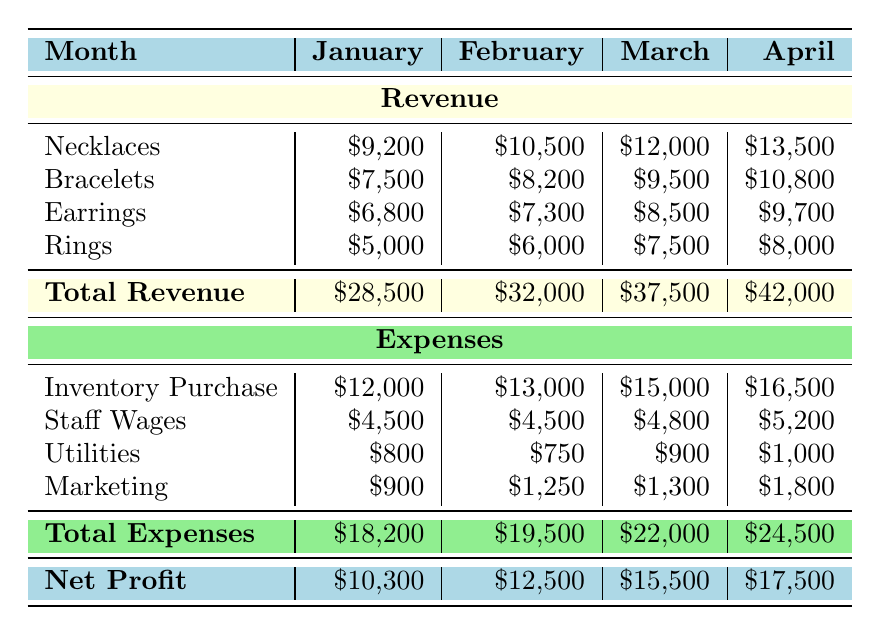What was the total revenue in February? The total revenue for February is listed directly under the "Total Revenue" row, which shows \$32,000.
Answer: \$32,000 Which category had the highest revenue in March? In March, the revenue breakdown shows that Necklaces had the highest revenue of \$12,000 compared to other categories.
Answer: Necklaces What is the average total revenue across the four months? The total revenues for the four months are \$28,500, \$32,000, \$37,500, and \$42,000. Summing them gives \$140,000. Dividing by 4 (the number of months), the average total revenue is \$35,000.
Answer: \$35,000 How much did the resort spend on staff wages in April? The expenses for staff wages in April are specified in the Expenses section as \$5,200.
Answer: \$5,200 True or False: The total expenses decreased from January to February. In January, the total expenses were \$18,200, and in February, they were \$19,500. Since \$19,500 is greater than \$18,200, the statement is false.
Answer: False Which month had the highest net profit? To find the highest net profit, we can compare the net profits across the months: January \$10,300, February \$12,500, March \$15,500, and April \$17,500. The highest is \$17,500 in April.
Answer: April What is the total amount spent on marketing for the first quarter? The marketing expenses for each month in the first quarter are: January \$900, February \$1,250, and March \$1,300. Summing these gives \$900 + \$1,250 + \$1,300 = \$3,450.
Answer: \$3,450 In which category did revenue increase the most from January to April? Calculating the changes from January to April: Necklaces increased by \$4,300 (from \$9,200 to \$13,500), Bracelets increased by \$3,300, Earrings increased by \$2,900, and Rings increased by \$3,000. The largest increase is in Necklaces.
Answer: Necklaces What was the total net profit for March and April combined? The net profit for March is \$15,500 and for April is \$17,500. Adding these two gives \$15,500 + \$17,500 = \$33,000.
Answer: \$33,000 Is the revenue from bracelets in February more than the expenses for utilities in February? The revenue from bracelets in February is \$8,200, while the expenses for utilities in February are \$750. Since \$8,200 is greater than \$750, the statement is true.
Answer: True 